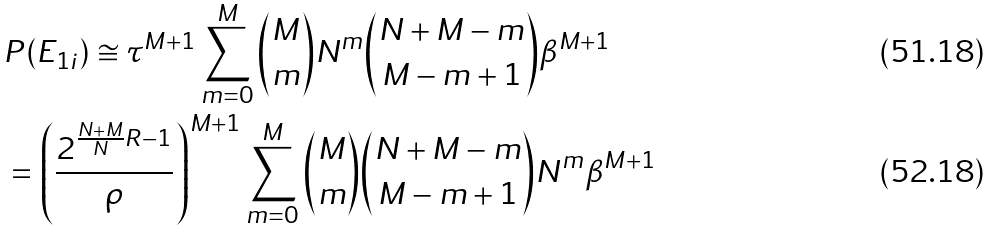Convert formula to latex. <formula><loc_0><loc_0><loc_500><loc_500>& P ( E _ { 1 i } ) \cong \tau ^ { M + 1 } \sum _ { m = 0 } ^ { M } \binom { M } { m } N ^ { m } \binom { N + M - m } { M - m + 1 } \beta ^ { M + 1 } \\ & = \left ( { \frac { 2 ^ { \frac { N + M } { N } R - 1 } } { \rho } } \right ) ^ { M + 1 } \sum _ { m = 0 } ^ { M } \binom { M } { m } \binom { N + M - m } { M - m + 1 } N ^ { m } \beta ^ { M + 1 }</formula> 